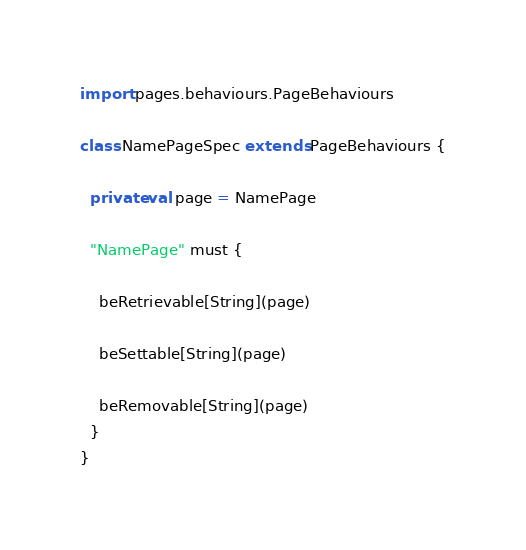Convert code to text. <code><loc_0><loc_0><loc_500><loc_500><_Scala_>
import pages.behaviours.PageBehaviours

class NamePageSpec extends PageBehaviours {

  private val page = NamePage

  "NamePage" must {

    beRetrievable[String](page)

    beSettable[String](page)

    beRemovable[String](page)
  }
}
</code> 